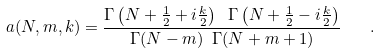<formula> <loc_0><loc_0><loc_500><loc_500>a ( N , m , k ) = \frac { \Gamma \left ( N + \frac { 1 } { 2 } + i \frac { k } { 2 } \right ) \ \Gamma \left ( N + \frac { 1 } { 2 } - i \frac { k } { 2 } \right ) } { \Gamma ( N - m ) \ \Gamma ( N + m + 1 ) } \quad .</formula> 